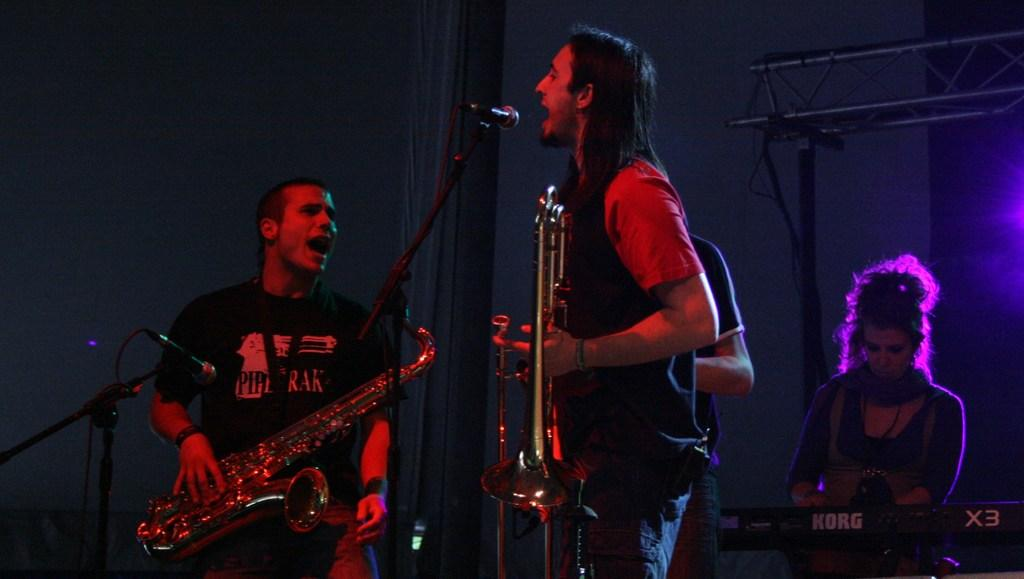What are the people in the image doing? The people in the image are singing and playing musical instruments. What activity are the people engaged in together? The people are participating in a musical performance, as they are singing and playing instruments. What color is the paint being used by the people in the image? There is no paint present in the image; the people are singing and playing musical instruments. 